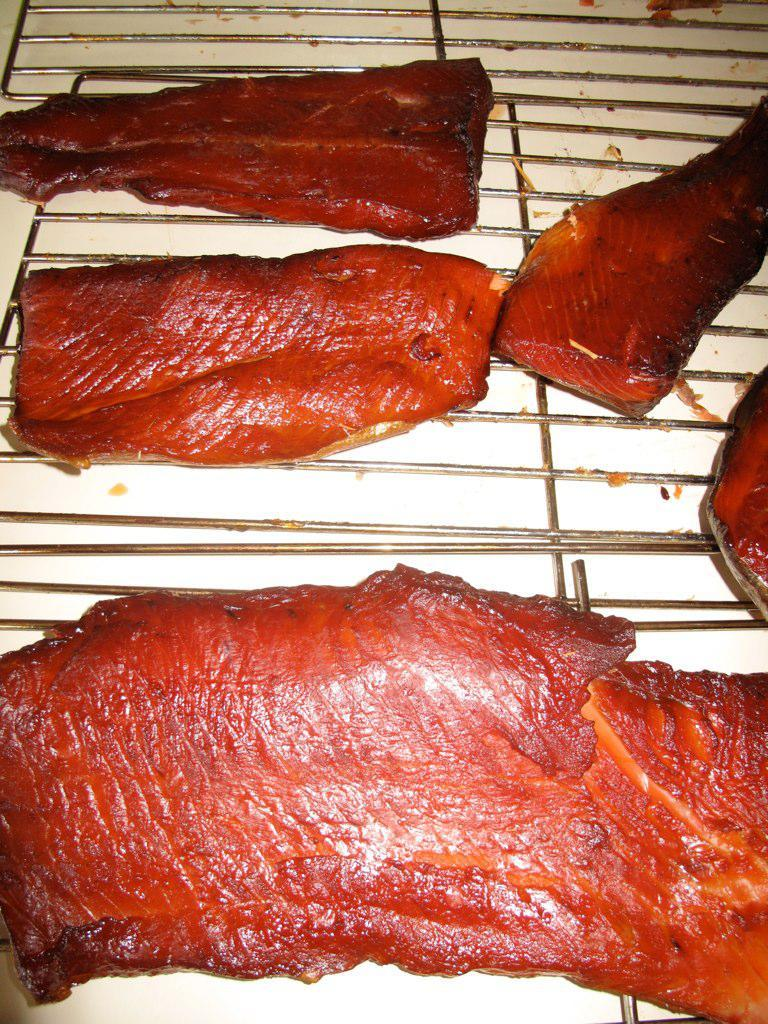What type of food can be seen in the image? There are meat pieces in the image. How are the meat pieces being prepared? The meat pieces are on grill plates. Where are the grill plates located? The grill plates are on a table. What type of vacation is being planned in the image? There is no indication of a vacation being planned in the image; it features meat pieces on grill plates on a table. What sound can be heard coming from the meat pieces in the image? There is no sound present in the image, as it is a still photograph. 